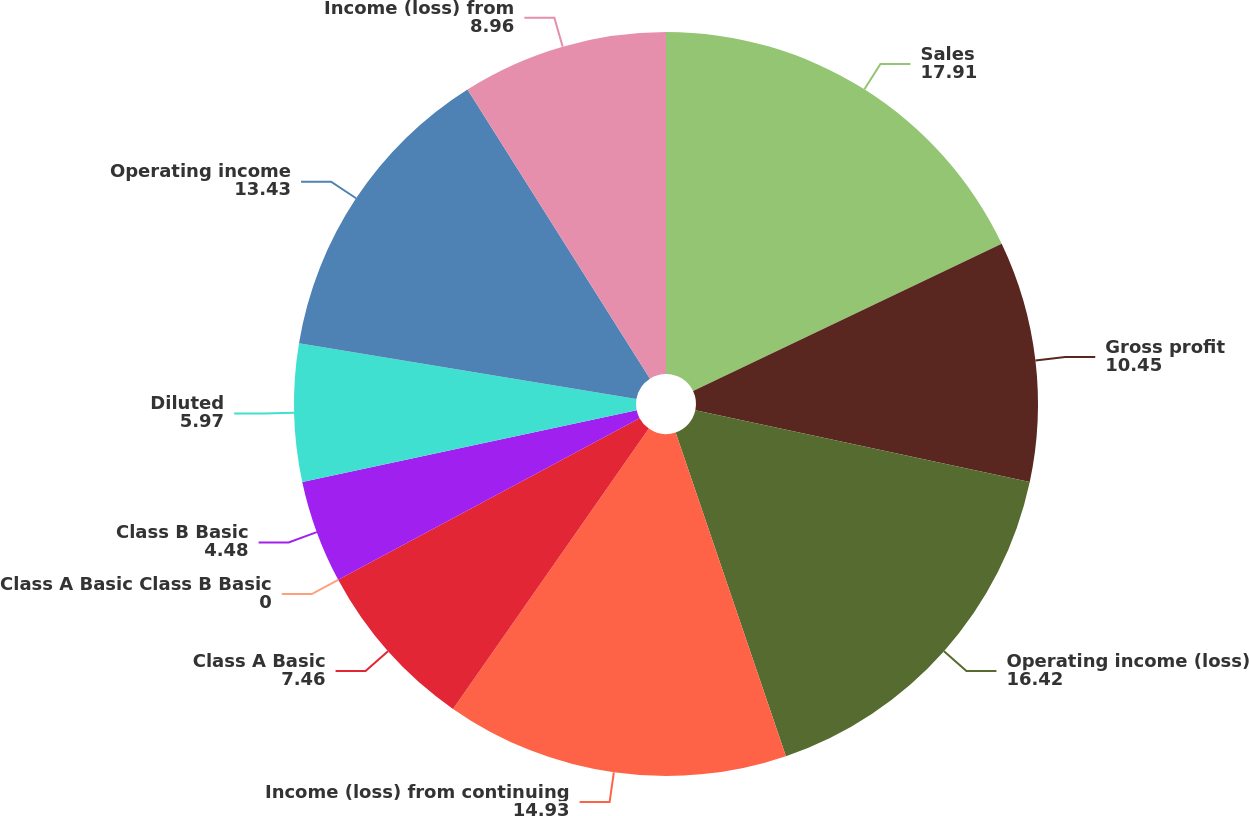<chart> <loc_0><loc_0><loc_500><loc_500><pie_chart><fcel>Sales<fcel>Gross profit<fcel>Operating income (loss)<fcel>Income (loss) from continuing<fcel>Class A Basic<fcel>Class A Basic Class B Basic<fcel>Class B Basic<fcel>Diluted<fcel>Operating income<fcel>Income (loss) from<nl><fcel>17.91%<fcel>10.45%<fcel>16.42%<fcel>14.93%<fcel>7.46%<fcel>0.0%<fcel>4.48%<fcel>5.97%<fcel>13.43%<fcel>8.96%<nl></chart> 